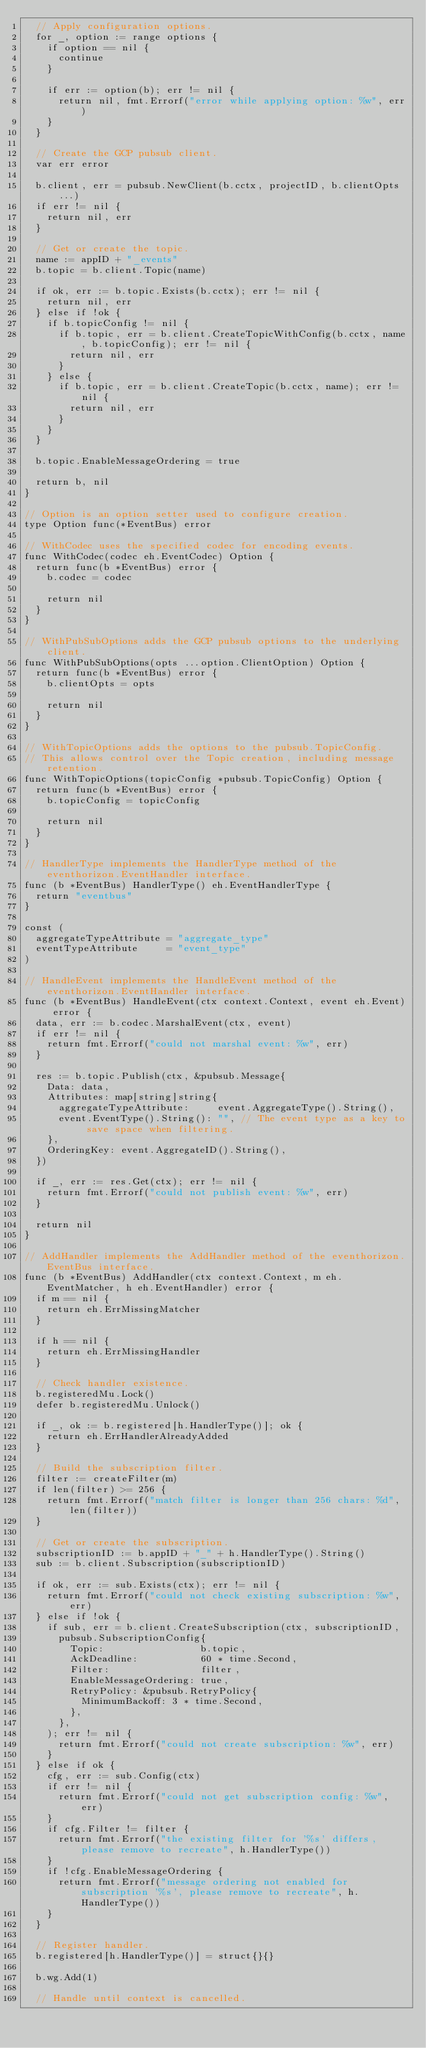<code> <loc_0><loc_0><loc_500><loc_500><_Go_>	// Apply configuration options.
	for _, option := range options {
		if option == nil {
			continue
		}

		if err := option(b); err != nil {
			return nil, fmt.Errorf("error while applying option: %w", err)
		}
	}

	// Create the GCP pubsub client.
	var err error

	b.client, err = pubsub.NewClient(b.cctx, projectID, b.clientOpts...)
	if err != nil {
		return nil, err
	}

	// Get or create the topic.
	name := appID + "_events"
	b.topic = b.client.Topic(name)

	if ok, err := b.topic.Exists(b.cctx); err != nil {
		return nil, err
	} else if !ok {
		if b.topicConfig != nil {
			if b.topic, err = b.client.CreateTopicWithConfig(b.cctx, name, b.topicConfig); err != nil {
				return nil, err
			}
		} else {
			if b.topic, err = b.client.CreateTopic(b.cctx, name); err != nil {
				return nil, err
			}
		}
	}

	b.topic.EnableMessageOrdering = true

	return b, nil
}

// Option is an option setter used to configure creation.
type Option func(*EventBus) error

// WithCodec uses the specified codec for encoding events.
func WithCodec(codec eh.EventCodec) Option {
	return func(b *EventBus) error {
		b.codec = codec

		return nil
	}
}

// WithPubSubOptions adds the GCP pubsub options to the underlying client.
func WithPubSubOptions(opts ...option.ClientOption) Option {
	return func(b *EventBus) error {
		b.clientOpts = opts

		return nil
	}
}

// WithTopicOptions adds the options to the pubsub.TopicConfig.
// This allows control over the Topic creation, including message retention.
func WithTopicOptions(topicConfig *pubsub.TopicConfig) Option {
	return func(b *EventBus) error {
		b.topicConfig = topicConfig

		return nil
	}
}

// HandlerType implements the HandlerType method of the eventhorizon.EventHandler interface.
func (b *EventBus) HandlerType() eh.EventHandlerType {
	return "eventbus"
}

const (
	aggregateTypeAttribute = "aggregate_type"
	eventTypeAttribute     = "event_type"
)

// HandleEvent implements the HandleEvent method of the eventhorizon.EventHandler interface.
func (b *EventBus) HandleEvent(ctx context.Context, event eh.Event) error {
	data, err := b.codec.MarshalEvent(ctx, event)
	if err != nil {
		return fmt.Errorf("could not marshal event: %w", err)
	}

	res := b.topic.Publish(ctx, &pubsub.Message{
		Data: data,
		Attributes: map[string]string{
			aggregateTypeAttribute:     event.AggregateType().String(),
			event.EventType().String(): "", // The event type as a key to save space when filtering.
		},
		OrderingKey: event.AggregateID().String(),
	})

	if _, err := res.Get(ctx); err != nil {
		return fmt.Errorf("could not publish event: %w", err)
	}

	return nil
}

// AddHandler implements the AddHandler method of the eventhorizon.EventBus interface.
func (b *EventBus) AddHandler(ctx context.Context, m eh.EventMatcher, h eh.EventHandler) error {
	if m == nil {
		return eh.ErrMissingMatcher
	}

	if h == nil {
		return eh.ErrMissingHandler
	}

	// Check handler existence.
	b.registeredMu.Lock()
	defer b.registeredMu.Unlock()

	if _, ok := b.registered[h.HandlerType()]; ok {
		return eh.ErrHandlerAlreadyAdded
	}

	// Build the subscription filter.
	filter := createFilter(m)
	if len(filter) >= 256 {
		return fmt.Errorf("match filter is longer than 256 chars: %d", len(filter))
	}

	// Get or create the subscription.
	subscriptionID := b.appID + "_" + h.HandlerType().String()
	sub := b.client.Subscription(subscriptionID)

	if ok, err := sub.Exists(ctx); err != nil {
		return fmt.Errorf("could not check existing subscription: %w", err)
	} else if !ok {
		if sub, err = b.client.CreateSubscription(ctx, subscriptionID,
			pubsub.SubscriptionConfig{
				Topic:                 b.topic,
				AckDeadline:           60 * time.Second,
				Filter:                filter,
				EnableMessageOrdering: true,
				RetryPolicy: &pubsub.RetryPolicy{
					MinimumBackoff: 3 * time.Second,
				},
			},
		); err != nil {
			return fmt.Errorf("could not create subscription: %w", err)
		}
	} else if ok {
		cfg, err := sub.Config(ctx)
		if err != nil {
			return fmt.Errorf("could not get subscription config: %w", err)
		}
		if cfg.Filter != filter {
			return fmt.Errorf("the existing filter for '%s' differs, please remove to recreate", h.HandlerType())
		}
		if !cfg.EnableMessageOrdering {
			return fmt.Errorf("message ordering not enabled for subscription '%s', please remove to recreate", h.HandlerType())
		}
	}

	// Register handler.
	b.registered[h.HandlerType()] = struct{}{}

	b.wg.Add(1)

	// Handle until context is cancelled.</code> 